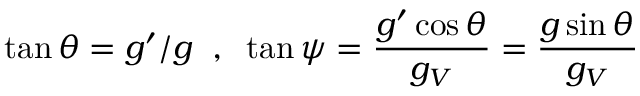<formula> <loc_0><loc_0><loc_500><loc_500>\tan \theta = g ^ { \prime } / g \, , \, \tan \psi = \frac { g ^ { \prime } \cos \theta } { g _ { V } } = \frac { g \sin \theta } { g _ { V } }</formula> 